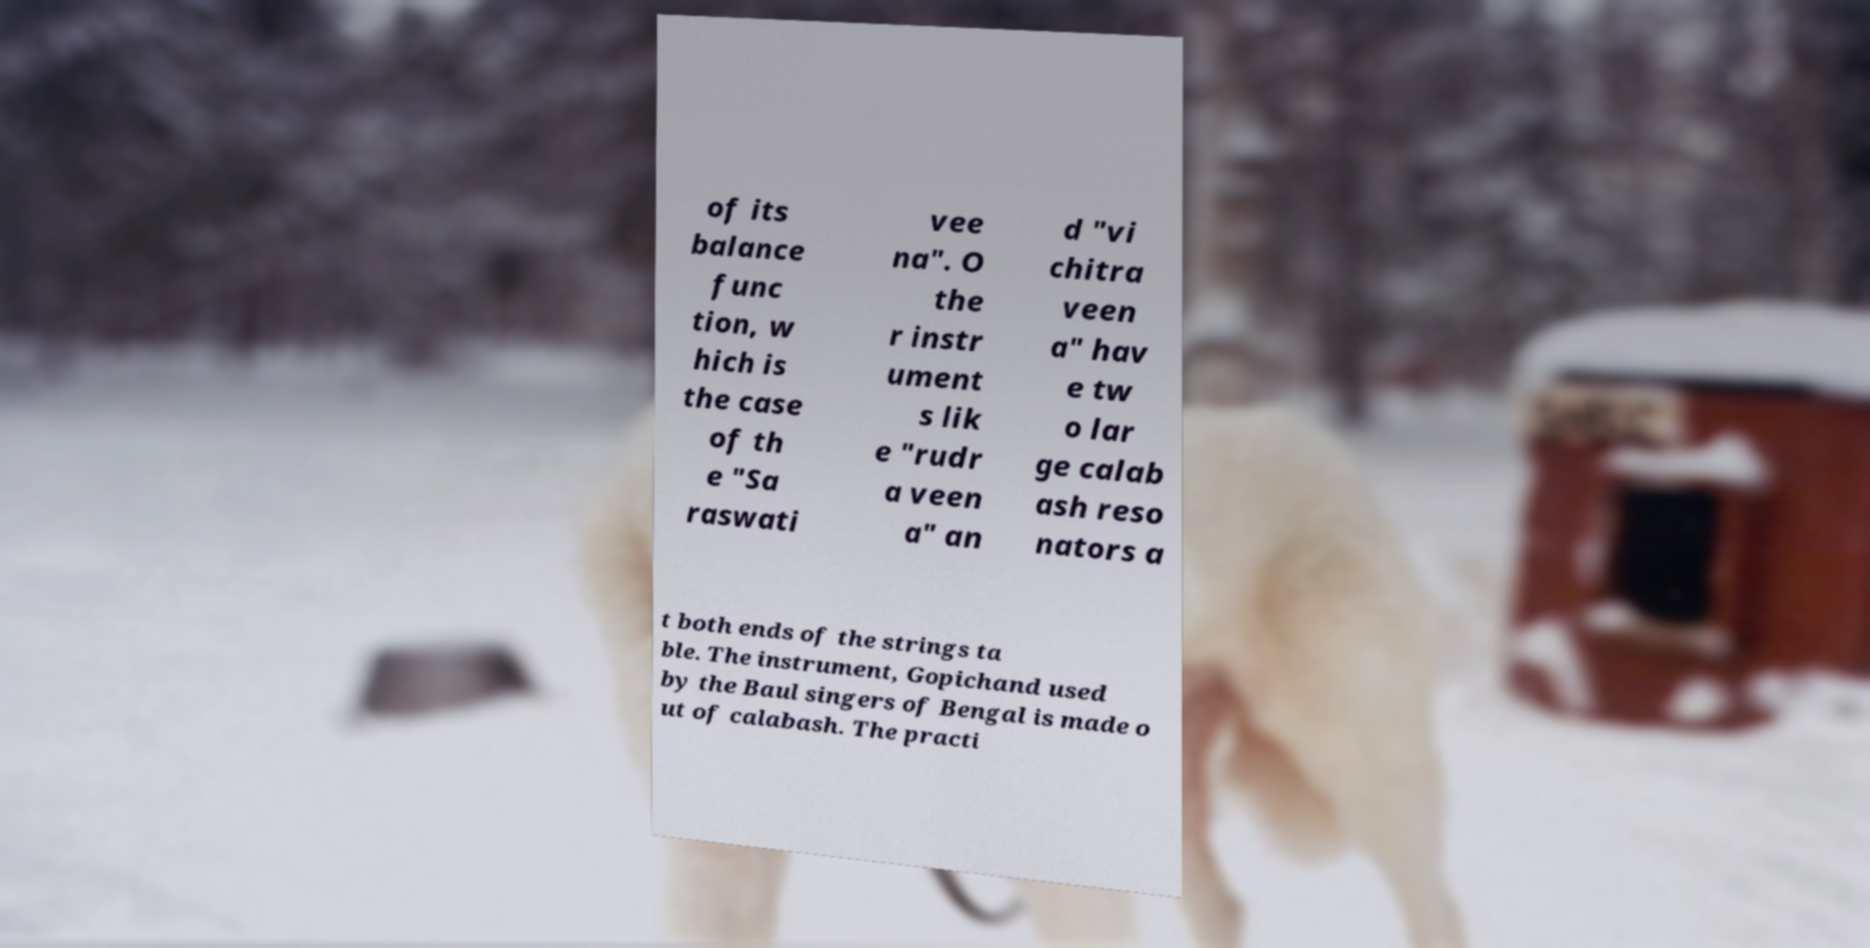Can you read and provide the text displayed in the image?This photo seems to have some interesting text. Can you extract and type it out for me? of its balance func tion, w hich is the case of th e "Sa raswati vee na". O the r instr ument s lik e "rudr a veen a" an d "vi chitra veen a" hav e tw o lar ge calab ash reso nators a t both ends of the strings ta ble. The instrument, Gopichand used by the Baul singers of Bengal is made o ut of calabash. The practi 